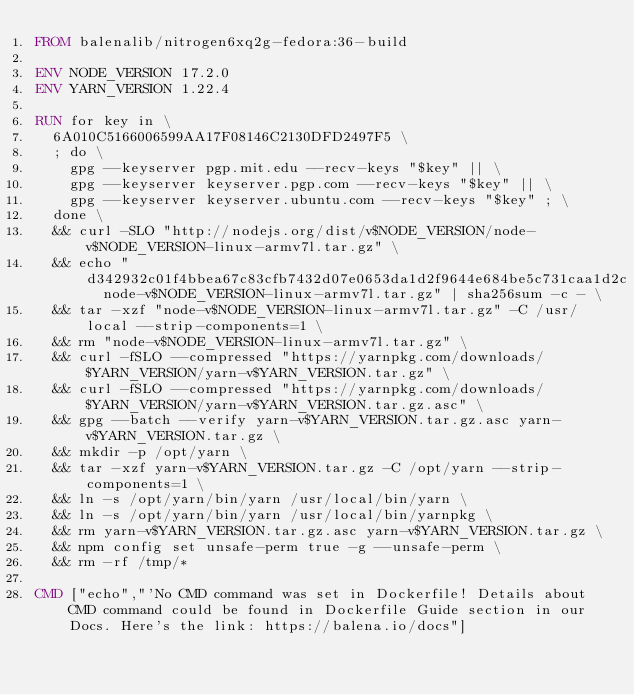Convert code to text. <code><loc_0><loc_0><loc_500><loc_500><_Dockerfile_>FROM balenalib/nitrogen6xq2g-fedora:36-build

ENV NODE_VERSION 17.2.0
ENV YARN_VERSION 1.22.4

RUN for key in \
	6A010C5166006599AA17F08146C2130DFD2497F5 \
	; do \
		gpg --keyserver pgp.mit.edu --recv-keys "$key" || \
		gpg --keyserver keyserver.pgp.com --recv-keys "$key" || \
		gpg --keyserver keyserver.ubuntu.com --recv-keys "$key" ; \
	done \
	&& curl -SLO "http://nodejs.org/dist/v$NODE_VERSION/node-v$NODE_VERSION-linux-armv7l.tar.gz" \
	&& echo "d342932c01f4bbea67c83cfb7432d07e0653da1d2f9644e684be5c731caa1d2c  node-v$NODE_VERSION-linux-armv7l.tar.gz" | sha256sum -c - \
	&& tar -xzf "node-v$NODE_VERSION-linux-armv7l.tar.gz" -C /usr/local --strip-components=1 \
	&& rm "node-v$NODE_VERSION-linux-armv7l.tar.gz" \
	&& curl -fSLO --compressed "https://yarnpkg.com/downloads/$YARN_VERSION/yarn-v$YARN_VERSION.tar.gz" \
	&& curl -fSLO --compressed "https://yarnpkg.com/downloads/$YARN_VERSION/yarn-v$YARN_VERSION.tar.gz.asc" \
	&& gpg --batch --verify yarn-v$YARN_VERSION.tar.gz.asc yarn-v$YARN_VERSION.tar.gz \
	&& mkdir -p /opt/yarn \
	&& tar -xzf yarn-v$YARN_VERSION.tar.gz -C /opt/yarn --strip-components=1 \
	&& ln -s /opt/yarn/bin/yarn /usr/local/bin/yarn \
	&& ln -s /opt/yarn/bin/yarn /usr/local/bin/yarnpkg \
	&& rm yarn-v$YARN_VERSION.tar.gz.asc yarn-v$YARN_VERSION.tar.gz \
	&& npm config set unsafe-perm true -g --unsafe-perm \
	&& rm -rf /tmp/*

CMD ["echo","'No CMD command was set in Dockerfile! Details about CMD command could be found in Dockerfile Guide section in our Docs. Here's the link: https://balena.io/docs"]
</code> 